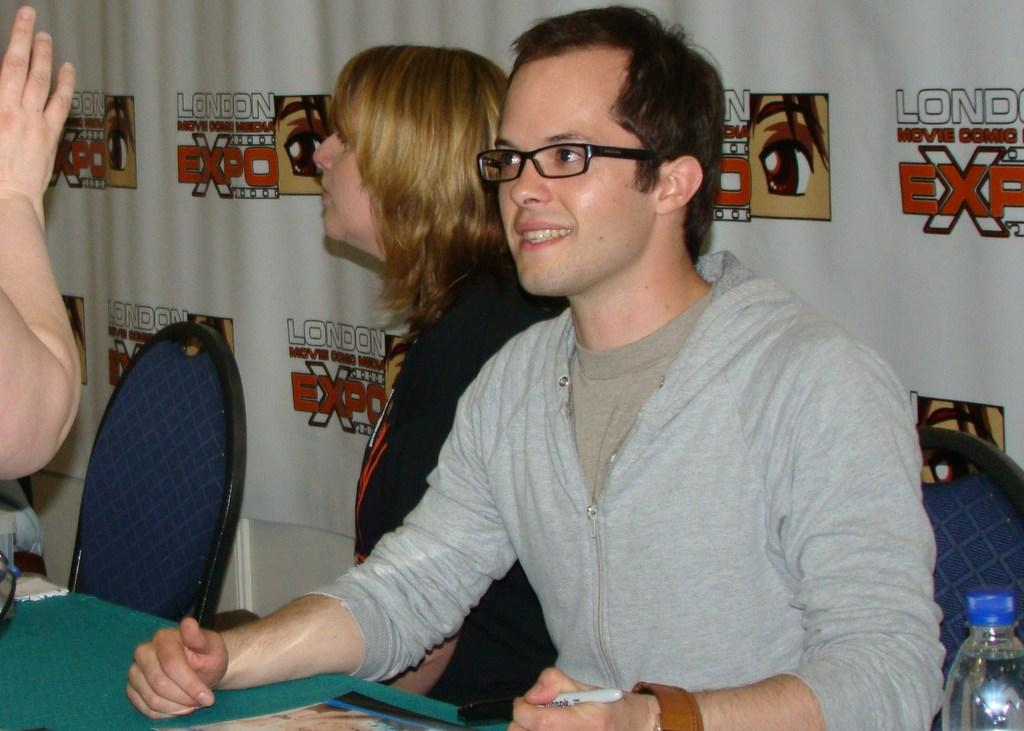What is the man in the image doing? The man is sitting on a chair in the image. Who is the man sitting beside in the image? The man is beside a woman in the image. What is the position of the man and the woman in relation to a table in the image? Both the man and the woman are in front of a table in the image. What type of church can be seen in the background of the image? There is no church visible in the background of the image. What is the plot of the story being told in the image? The image does not depict a story or plot; it simply shows a man sitting on a chair beside a woman. 